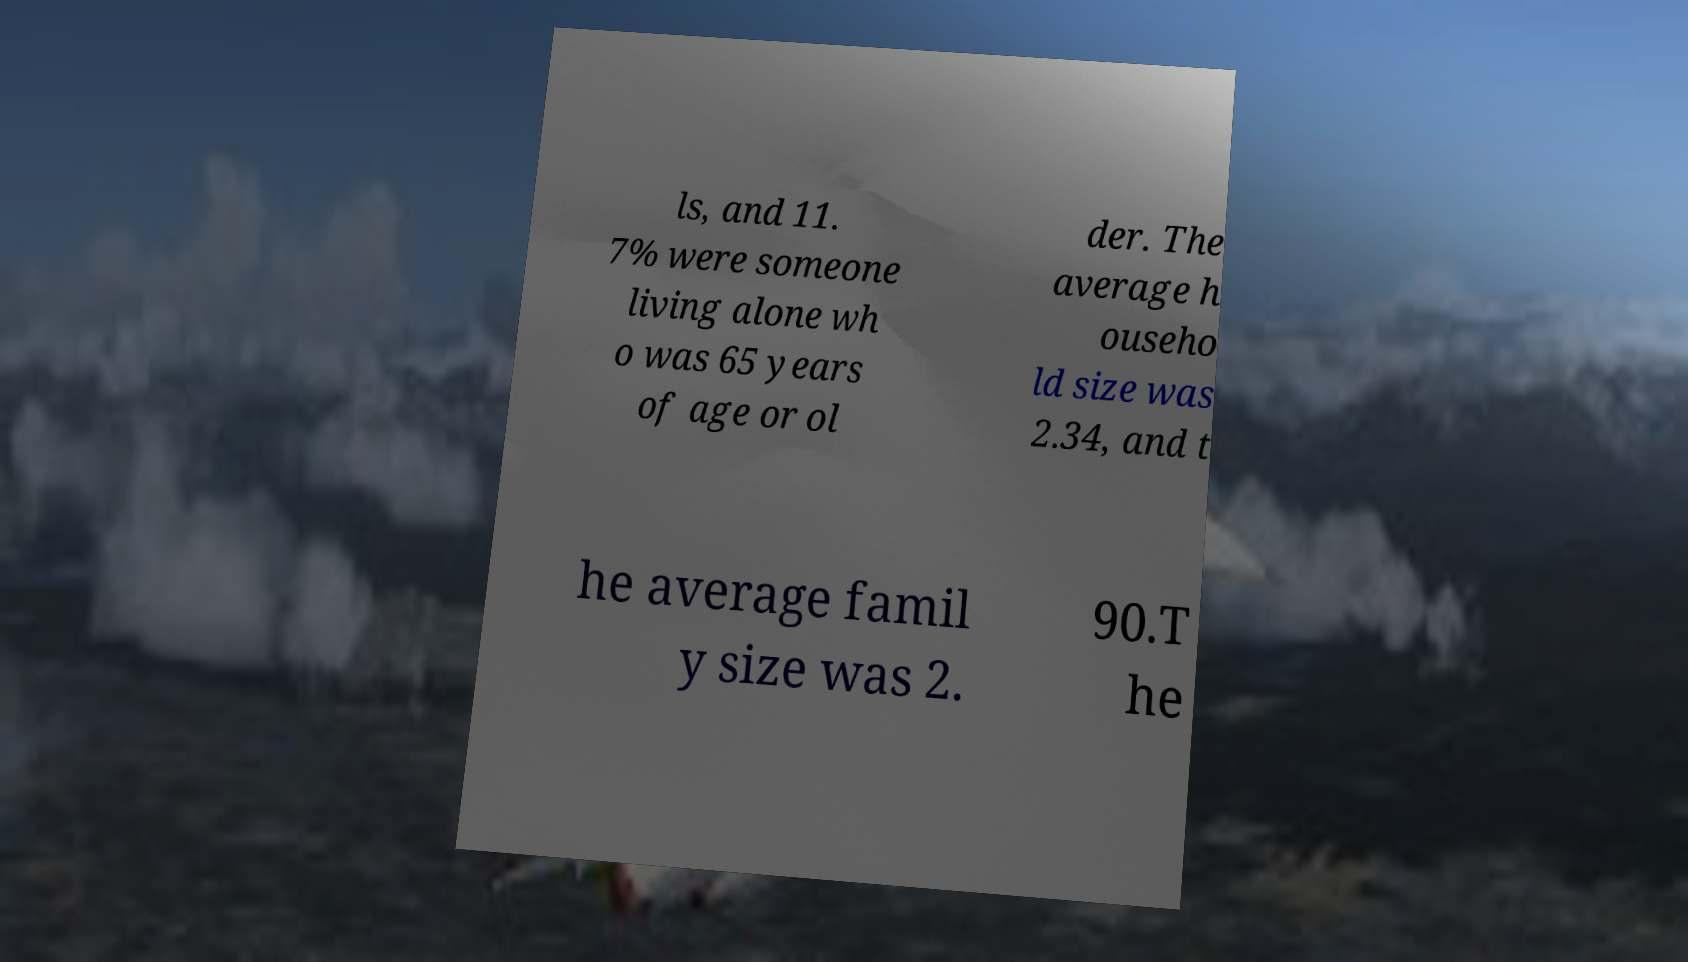Can you read and provide the text displayed in the image?This photo seems to have some interesting text. Can you extract and type it out for me? ls, and 11. 7% were someone living alone wh o was 65 years of age or ol der. The average h ouseho ld size was 2.34, and t he average famil y size was 2. 90.T he 